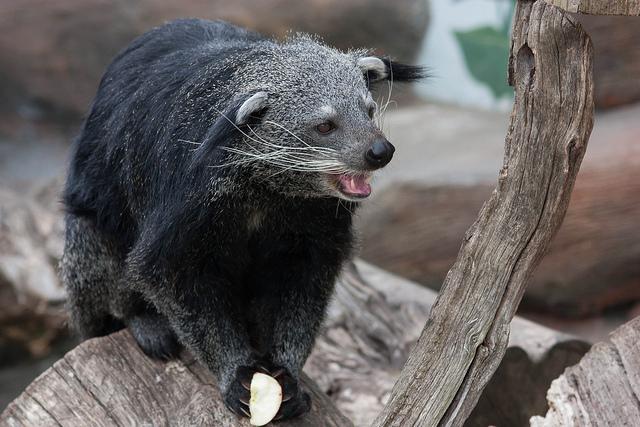Does this animal look like it is smiling?
Quick response, please. Yes. Does this animal have claws?
Concise answer only. Yes. What is this animal?
Write a very short answer. Bear. 